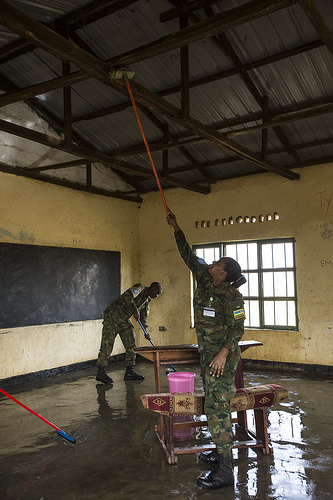<image>
Is there a uniform on the person? No. The uniform is not positioned on the person. They may be near each other, but the uniform is not supported by or resting on top of the person. 